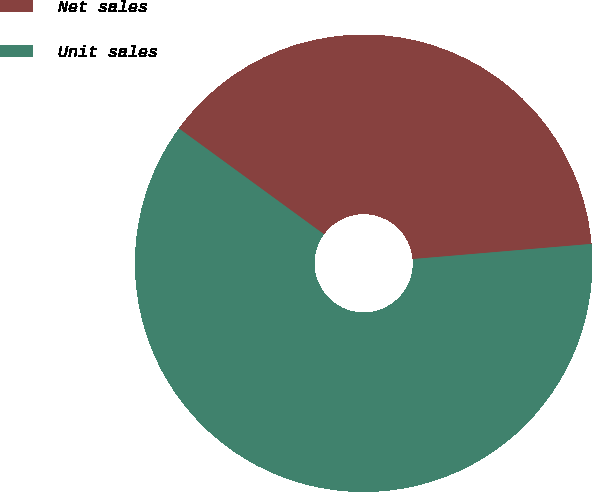Convert chart. <chart><loc_0><loc_0><loc_500><loc_500><pie_chart><fcel>Net sales<fcel>Unit sales<nl><fcel>38.62%<fcel>61.38%<nl></chart> 